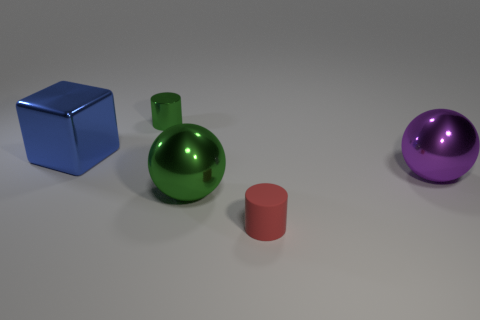Add 4 cubes. How many objects exist? 9 Subtract all blocks. How many objects are left? 4 Add 2 large yellow metallic cylinders. How many large yellow metallic cylinders exist? 2 Subtract 0 brown cubes. How many objects are left? 5 Subtract all large shiny blocks. Subtract all small matte cylinders. How many objects are left? 3 Add 2 tiny red things. How many tiny red things are left? 3 